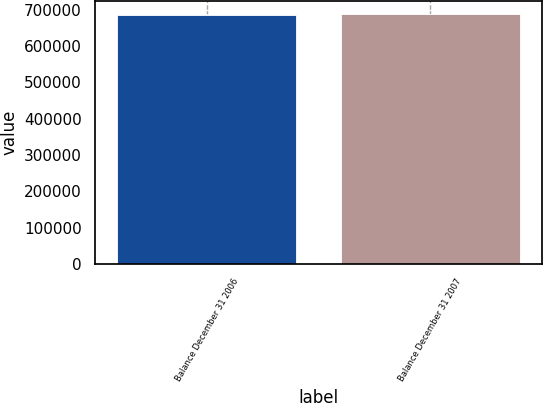<chart> <loc_0><loc_0><loc_500><loc_500><bar_chart><fcel>Balance December 31 2006<fcel>Balance December 31 2007<nl><fcel>686301<fcel>688842<nl></chart> 